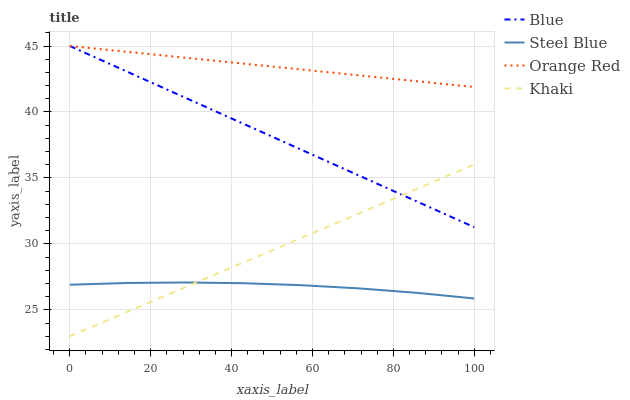Does Khaki have the minimum area under the curve?
Answer yes or no. No. Does Khaki have the maximum area under the curve?
Answer yes or no. No. Is Khaki the smoothest?
Answer yes or no. No. Is Khaki the roughest?
Answer yes or no. No. Does Steel Blue have the lowest value?
Answer yes or no. No. Does Khaki have the highest value?
Answer yes or no. No. Is Steel Blue less than Orange Red?
Answer yes or no. Yes. Is Orange Red greater than Steel Blue?
Answer yes or no. Yes. Does Steel Blue intersect Orange Red?
Answer yes or no. No. 